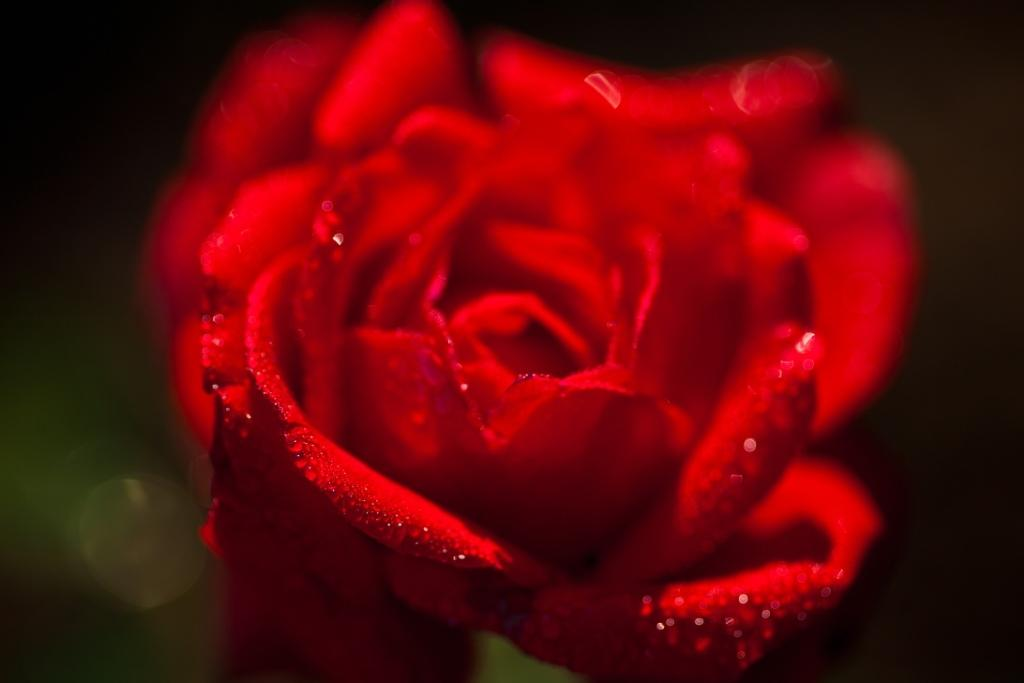What type of flower is in the image? There is a rose in the image. Can you describe the appearance of the rose? The rose has water droplets on its petals. What is the focus of the image? The focus of the image is the rose, while the area around it is blurred. What is the title of the book that the rose is holding in the image? There is no book or title present in the image; it features a rose with water droplets on its petals. 